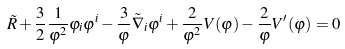<formula> <loc_0><loc_0><loc_500><loc_500>\tilde { R } + \frac { 3 } { 2 } \frac { 1 } { \varphi ^ { 2 } } \varphi _ { i } \varphi ^ { i } - \frac { 3 } { \varphi } \tilde { \nabla } _ { i } \varphi ^ { i } + \frac { 2 } { \varphi ^ { 2 } } V ( \varphi ) - \frac { 2 } { \varphi } V ^ { \prime } ( \varphi ) = 0</formula> 